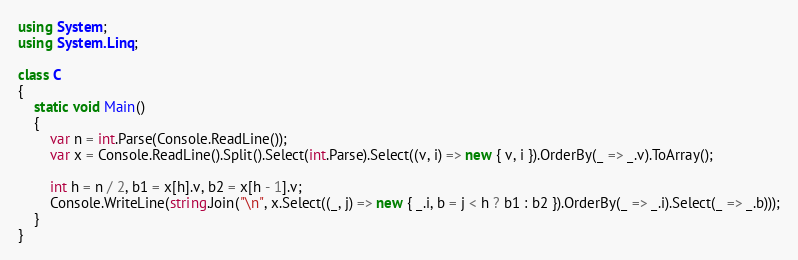Convert code to text. <code><loc_0><loc_0><loc_500><loc_500><_C#_>using System;
using System.Linq;

class C
{
	static void Main()
	{
		var n = int.Parse(Console.ReadLine());
		var x = Console.ReadLine().Split().Select(int.Parse).Select((v, i) => new { v, i }).OrderBy(_ => _.v).ToArray();

		int h = n / 2, b1 = x[h].v, b2 = x[h - 1].v;
		Console.WriteLine(string.Join("\n", x.Select((_, j) => new { _.i, b = j < h ? b1 : b2 }).OrderBy(_ => _.i).Select(_ => _.b)));
	}
}
</code> 